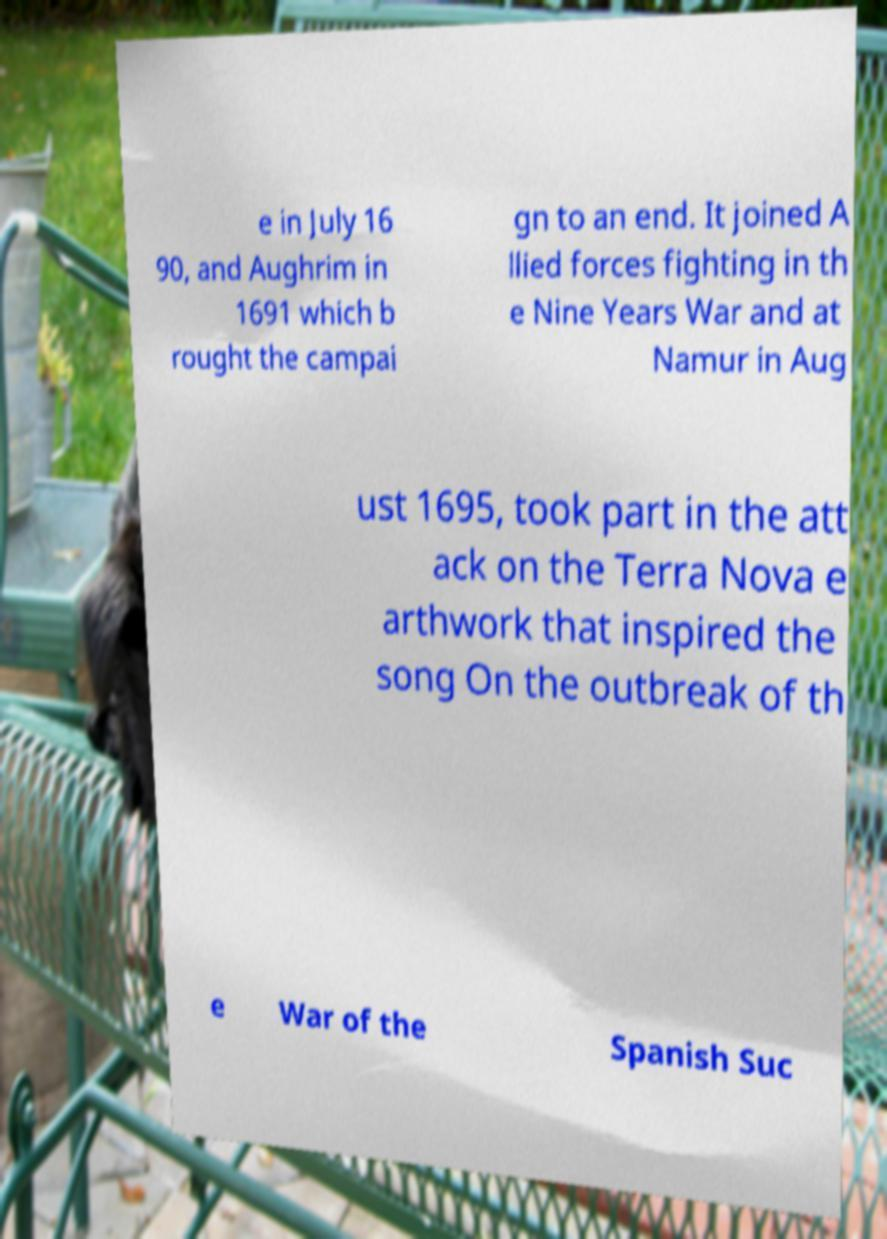Could you assist in decoding the text presented in this image and type it out clearly? e in July 16 90, and Aughrim in 1691 which b rought the campai gn to an end. It joined A llied forces fighting in th e Nine Years War and at Namur in Aug ust 1695, took part in the att ack on the Terra Nova e arthwork that inspired the song On the outbreak of th e War of the Spanish Suc 